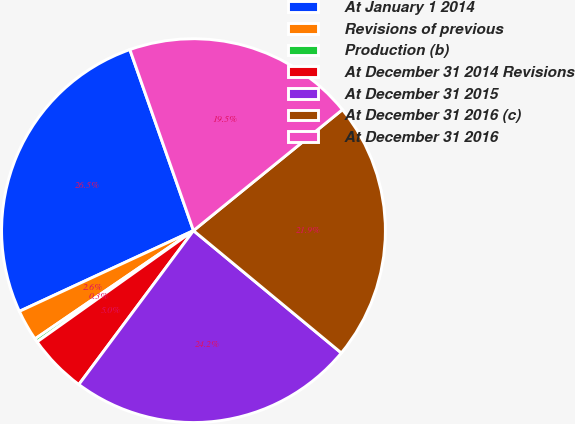Convert chart. <chart><loc_0><loc_0><loc_500><loc_500><pie_chart><fcel>At January 1 2014<fcel>Revisions of previous<fcel>Production (b)<fcel>At December 31 2014 Revisions<fcel>At December 31 2015<fcel>At December 31 2016 (c)<fcel>At December 31 2016<nl><fcel>26.53%<fcel>2.63%<fcel>0.3%<fcel>4.97%<fcel>24.19%<fcel>21.86%<fcel>19.52%<nl></chart> 